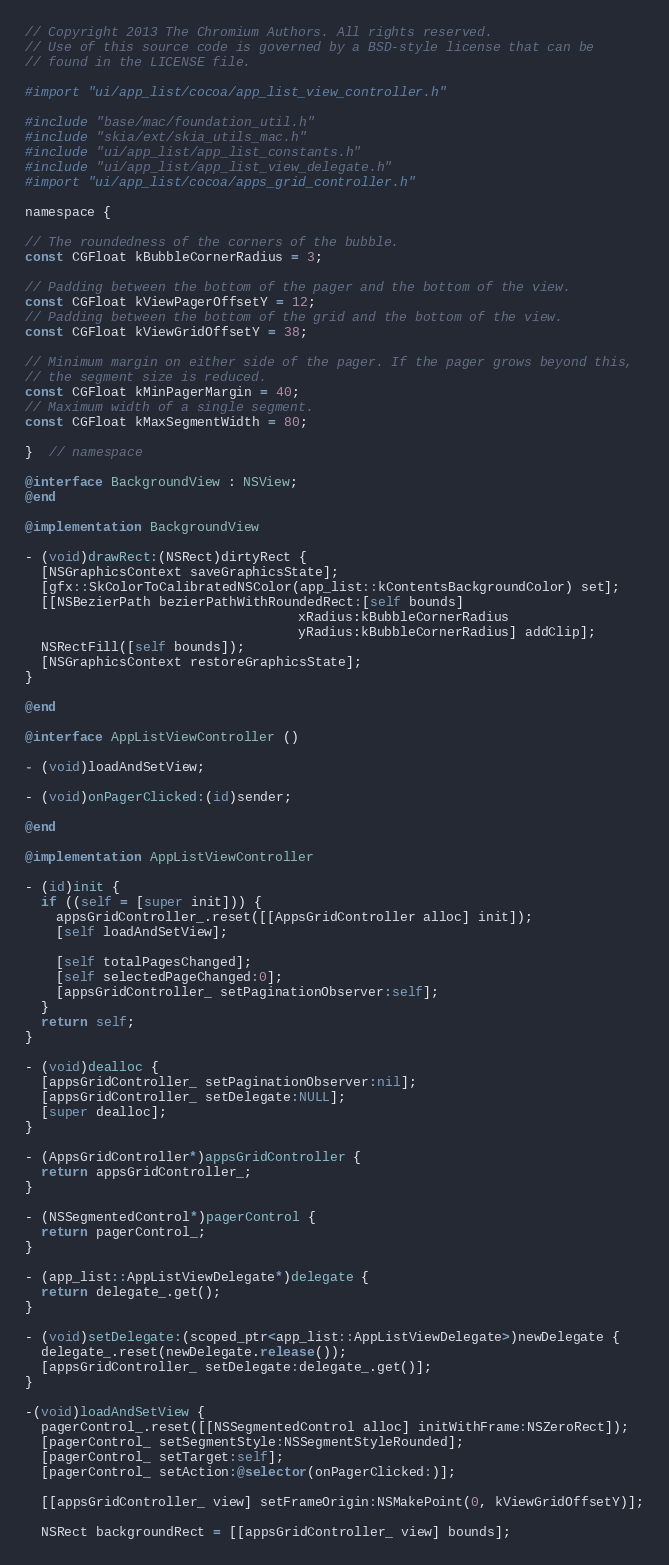Convert code to text. <code><loc_0><loc_0><loc_500><loc_500><_ObjectiveC_>// Copyright 2013 The Chromium Authors. All rights reserved.
// Use of this source code is governed by a BSD-style license that can be
// found in the LICENSE file.

#import "ui/app_list/cocoa/app_list_view_controller.h"

#include "base/mac/foundation_util.h"
#include "skia/ext/skia_utils_mac.h"
#include "ui/app_list/app_list_constants.h"
#include "ui/app_list/app_list_view_delegate.h"
#import "ui/app_list/cocoa/apps_grid_controller.h"

namespace {

// The roundedness of the corners of the bubble.
const CGFloat kBubbleCornerRadius = 3;

// Padding between the bottom of the pager and the bottom of the view.
const CGFloat kViewPagerOffsetY = 12;
// Padding between the bottom of the grid and the bottom of the view.
const CGFloat kViewGridOffsetY = 38;

// Minimum margin on either side of the pager. If the pager grows beyond this,
// the segment size is reduced.
const CGFloat kMinPagerMargin = 40;
// Maximum width of a single segment.
const CGFloat kMaxSegmentWidth = 80;

}  // namespace

@interface BackgroundView : NSView;
@end

@implementation BackgroundView

- (void)drawRect:(NSRect)dirtyRect {
  [NSGraphicsContext saveGraphicsState];
  [gfx::SkColorToCalibratedNSColor(app_list::kContentsBackgroundColor) set];
  [[NSBezierPath bezierPathWithRoundedRect:[self bounds]
                                   xRadius:kBubbleCornerRadius
                                   yRadius:kBubbleCornerRadius] addClip];
  NSRectFill([self bounds]);
  [NSGraphicsContext restoreGraphicsState];
}

@end

@interface AppListViewController ()

- (void)loadAndSetView;

- (void)onPagerClicked:(id)sender;

@end

@implementation AppListViewController

- (id)init {
  if ((self = [super init])) {
    appsGridController_.reset([[AppsGridController alloc] init]);
    [self loadAndSetView];

    [self totalPagesChanged];
    [self selectedPageChanged:0];
    [appsGridController_ setPaginationObserver:self];
  }
  return self;
}

- (void)dealloc {
  [appsGridController_ setPaginationObserver:nil];
  [appsGridController_ setDelegate:NULL];
  [super dealloc];
}

- (AppsGridController*)appsGridController {
  return appsGridController_;
}

- (NSSegmentedControl*)pagerControl {
  return pagerControl_;
}

- (app_list::AppListViewDelegate*)delegate {
  return delegate_.get();
}

- (void)setDelegate:(scoped_ptr<app_list::AppListViewDelegate>)newDelegate {
  delegate_.reset(newDelegate.release());
  [appsGridController_ setDelegate:delegate_.get()];
}

-(void)loadAndSetView {
  pagerControl_.reset([[NSSegmentedControl alloc] initWithFrame:NSZeroRect]);
  [pagerControl_ setSegmentStyle:NSSegmentStyleRounded];
  [pagerControl_ setTarget:self];
  [pagerControl_ setAction:@selector(onPagerClicked:)];

  [[appsGridController_ view] setFrameOrigin:NSMakePoint(0, kViewGridOffsetY)];

  NSRect backgroundRect = [[appsGridController_ view] bounds];</code> 